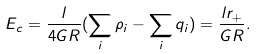<formula> <loc_0><loc_0><loc_500><loc_500>E _ { c } = \frac { l } { 4 G R } ( \sum _ { i } \rho _ { i } - \sum _ { i } q _ { i } ) = \frac { l r _ { + } } { G R } .</formula> 